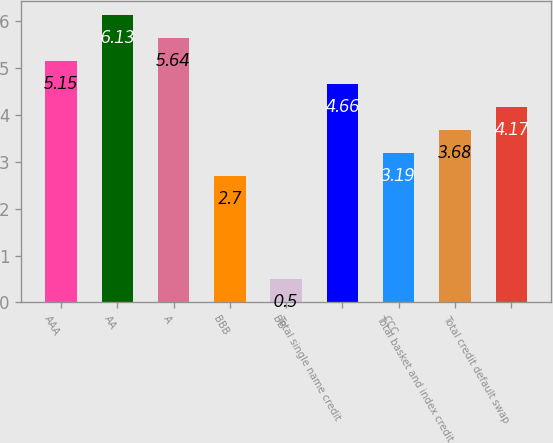<chart> <loc_0><loc_0><loc_500><loc_500><bar_chart><fcel>AAA<fcel>AA<fcel>A<fcel>BBB<fcel>BB<fcel>Total single name credit<fcel>CCC<fcel>Total basket and index credit<fcel>Total credit default swap<nl><fcel>5.15<fcel>6.13<fcel>5.64<fcel>2.7<fcel>0.5<fcel>4.66<fcel>3.19<fcel>3.68<fcel>4.17<nl></chart> 